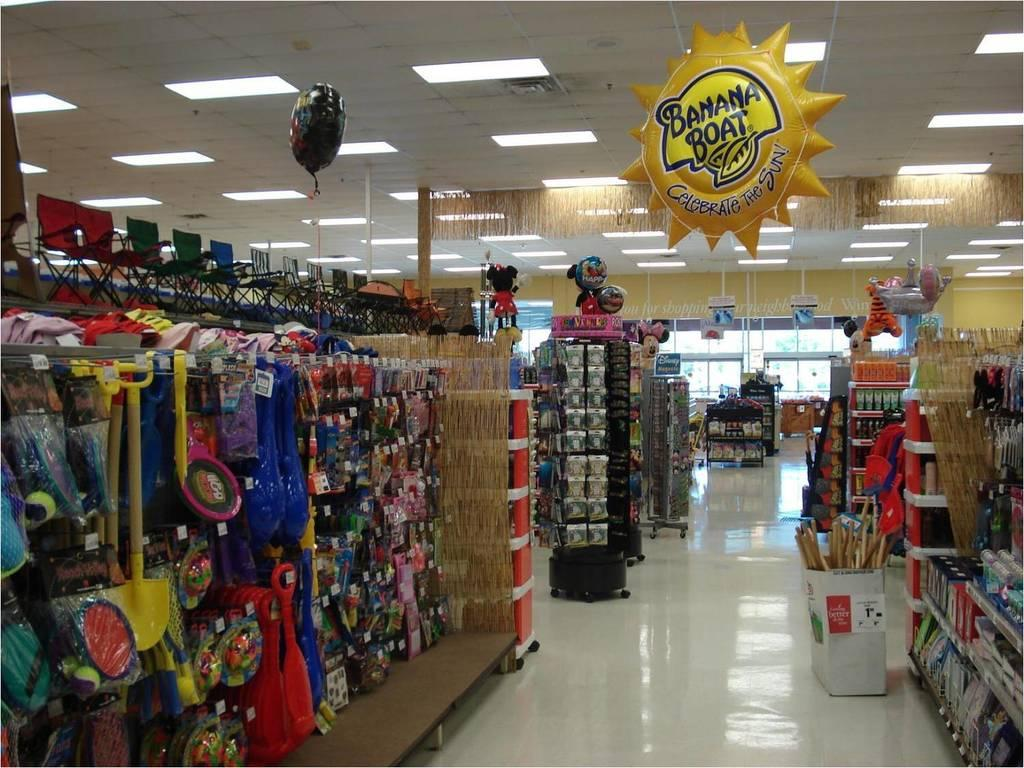<image>
Give a short and clear explanation of the subsequent image. The inside of a retail store in the toy isle with a Banana Boat advertising balloon overhead. 